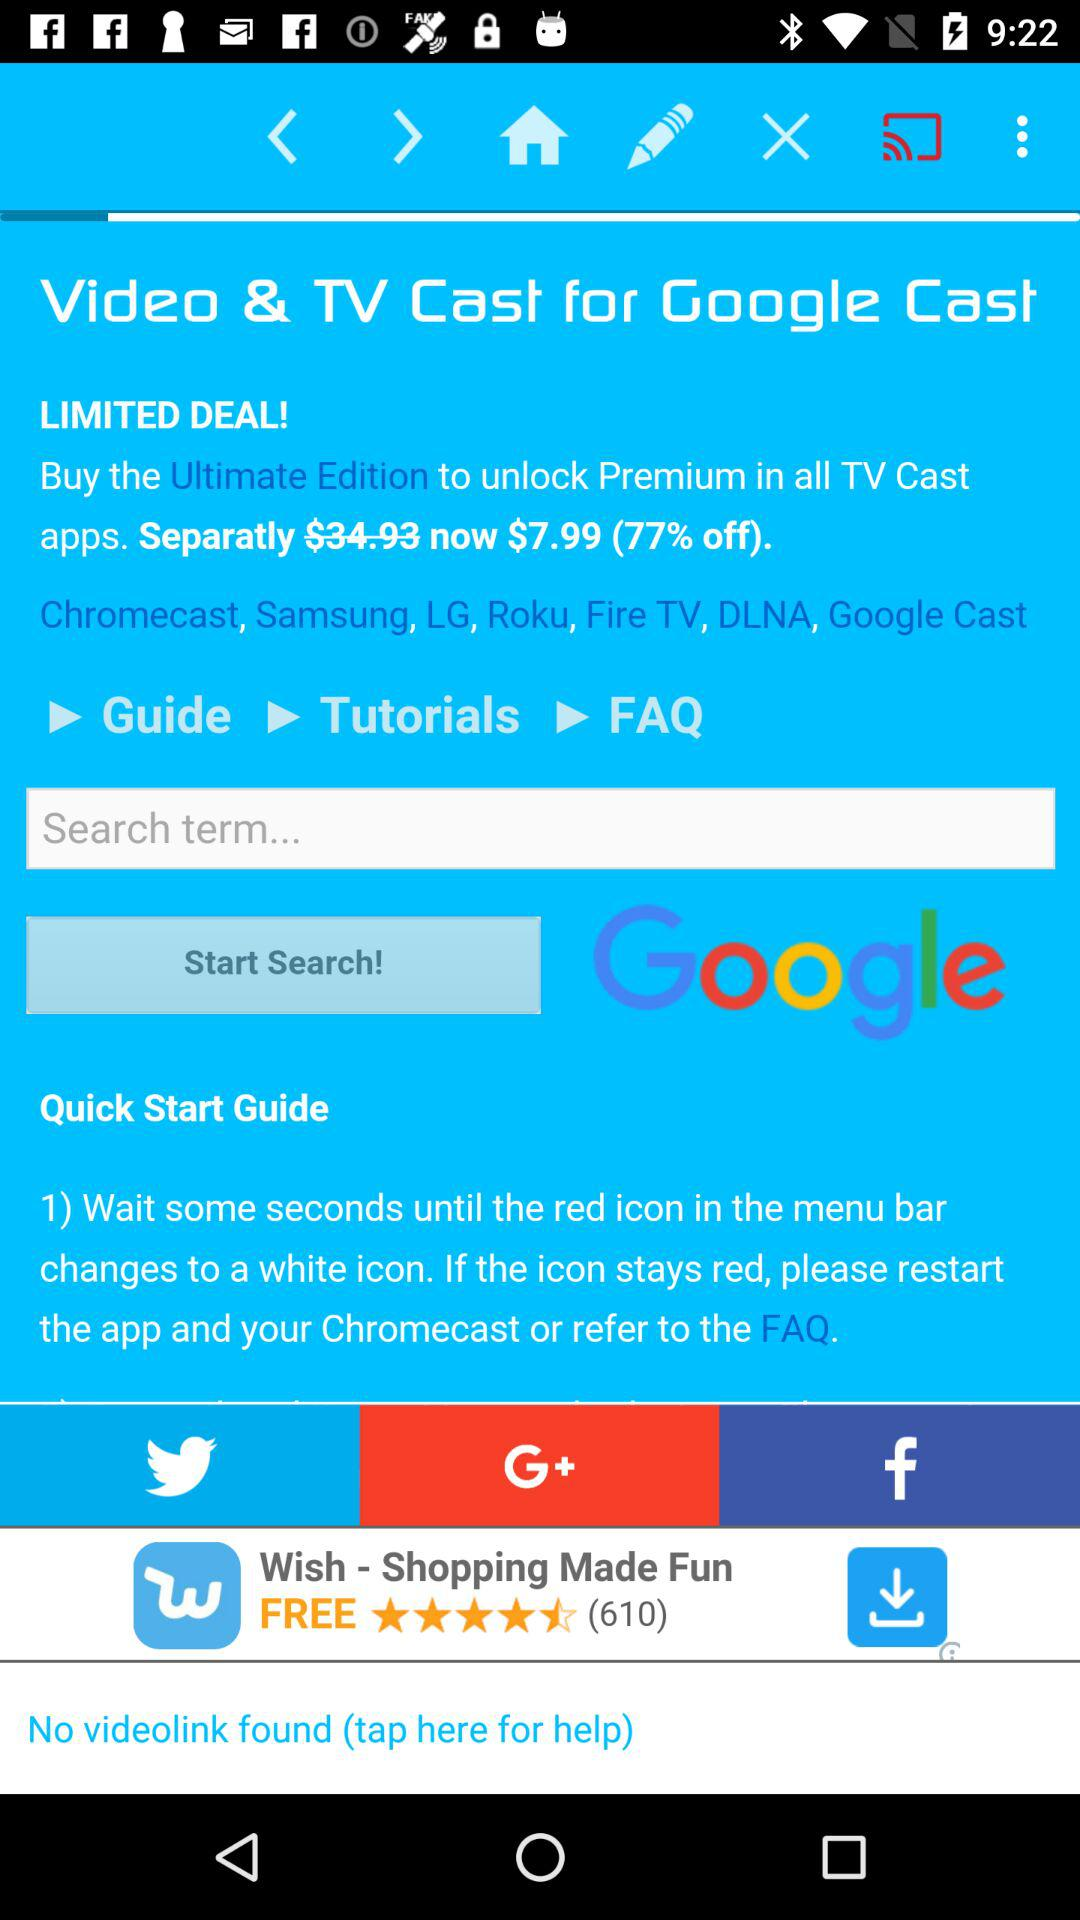What is the discount percent of the premium pack? The discount percent of the premium pack is 77%. 